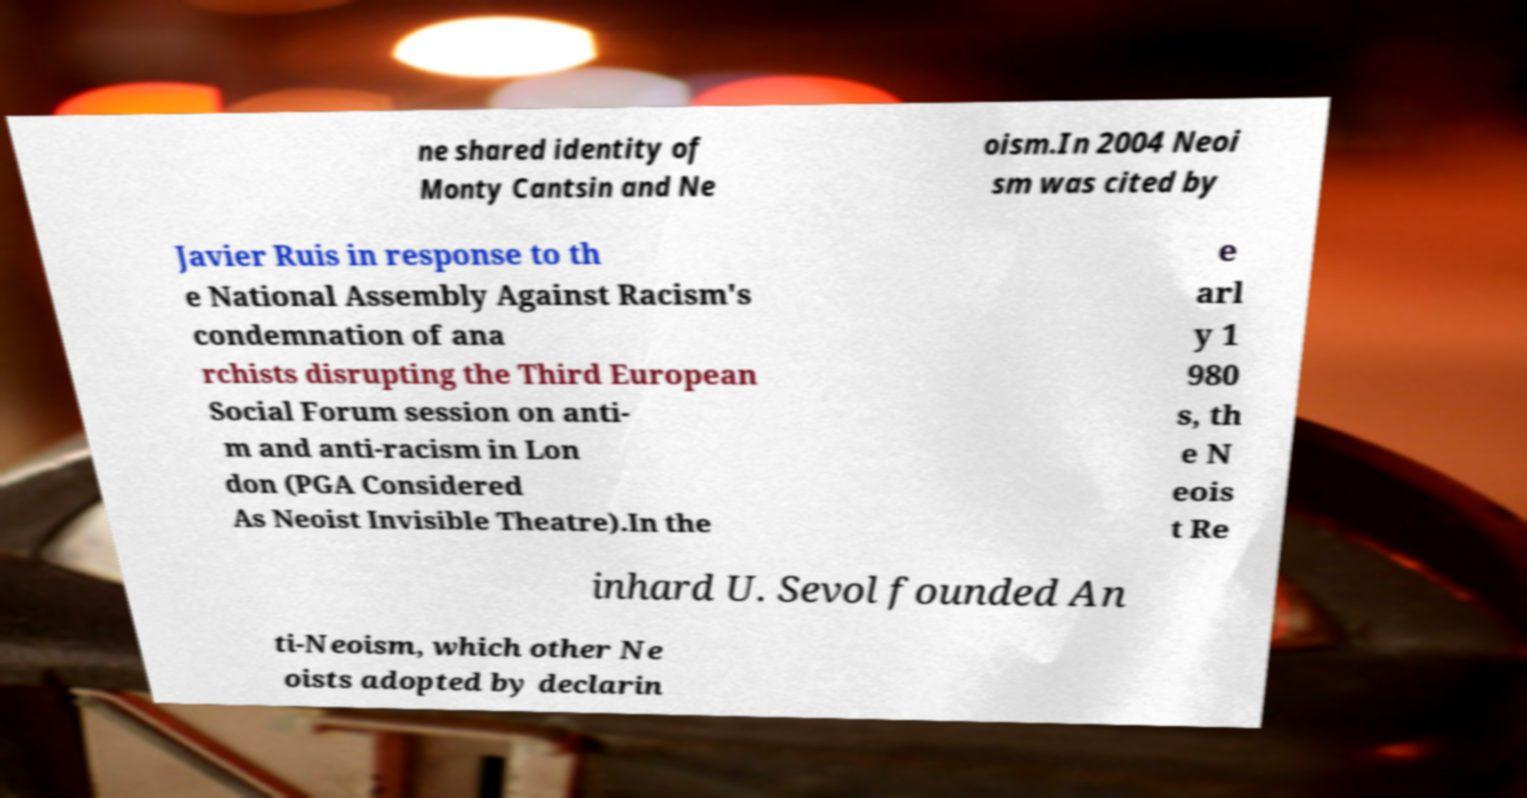Please read and relay the text visible in this image. What does it say? ne shared identity of Monty Cantsin and Ne oism.In 2004 Neoi sm was cited by Javier Ruis in response to th e National Assembly Against Racism's condemnation of ana rchists disrupting the Third European Social Forum session on anti- m and anti-racism in Lon don (PGA Considered As Neoist Invisible Theatre).In the e arl y 1 980 s, th e N eois t Re inhard U. Sevol founded An ti-Neoism, which other Ne oists adopted by declarin 